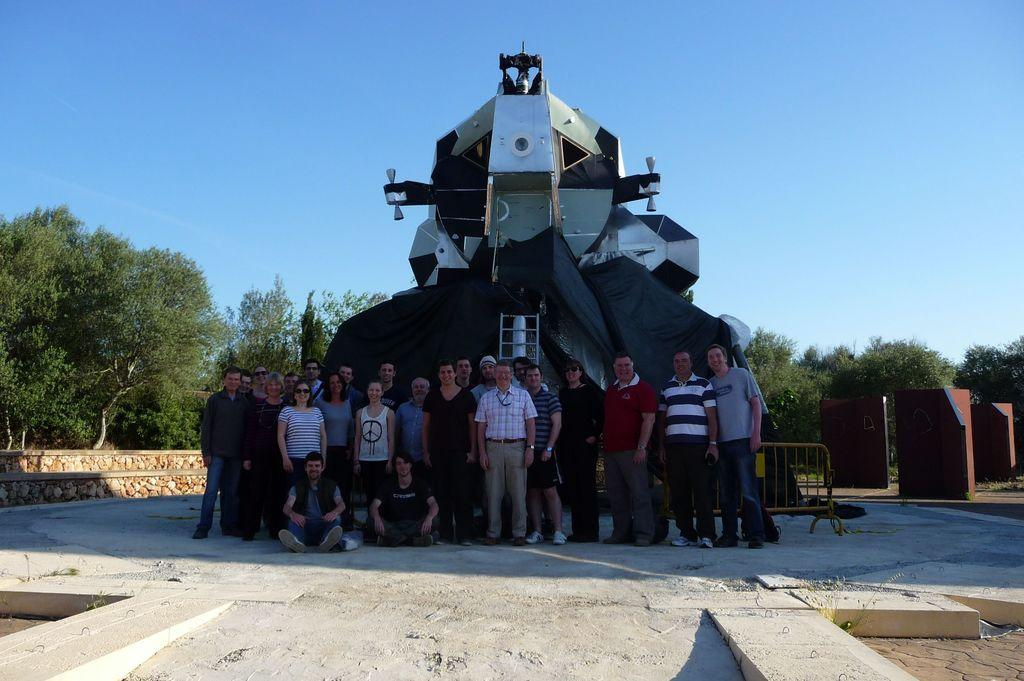How many people are present in the image? There are many people in the image. What can be seen in the background of the image? There appears to be a plane and trees in the background. What is at the bottom of the image? There is a floor at the bottom of the image. What is visible at the top of the image? The sky is visible at the top of the image. What type of quilt is being used to cover the eggs in the image? There are no eggs or quilts present in the image. What thrilling activity are the people participating in the image? The image does not depict any specific activity, so it is not possible to determine if it is thrilling or not. 